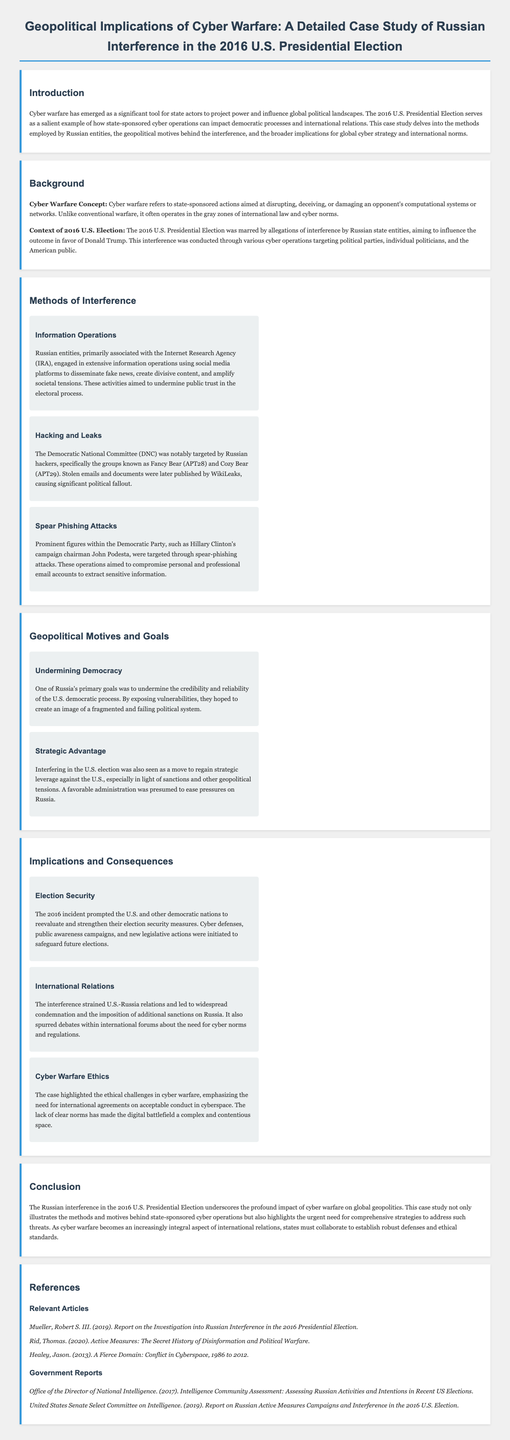What is the primary example of cyber warfare discussed in the document? The document discusses Russian interference in the 2016 U.S. Presidential Election as the primary example of cyber warfare.
Answer: Russian interference in the 2016 U.S. Presidential Election Who primarily conducted information operations in the 2016 U.S. Presidential Election? The document states that Russian entities associated with the Internet Research Agency (IRA) engaged in information operations.
Answer: Internet Research Agency (IRA) What hacking groups targeted the Democratic National Committee? The document names Fancy Bear (APT28) and Cozy Bear (APT29) as the hacking groups that targeted the DNC.
Answer: Fancy Bear (APT28) and Cozy Bear (APT29) What was one goal of Russia's interference in the election? The document mentions that undermining the credibility and reliability of the U.S. democratic process was one of Russia's primary goals.
Answer: Undermining democracy What consequence did the 2016 incident have on election security? The document highlights that the incident prompted the U.S. and other nations to reevaluate and strengthen their election security measures.
Answer: Strengthening election security measures What type of ethical challenges are highlighted by the case? The document emphasizes the need for international agreements on acceptable conduct in cyberspace as a challenge.
Answer: Cyber warfare ethics What is one implication on international relations due to the interference? The document states that the interference strained U.S.-Russia relations and led to additional sanctions on Russia.
Answer: Strained U.S.-Russia relations What does the case study suggest about collaboration among states? The document implies that states must collaborate to establish robust defenses and ethical standards due to cyber warfare.
Answer: Collaboration to establish defenses and standards 